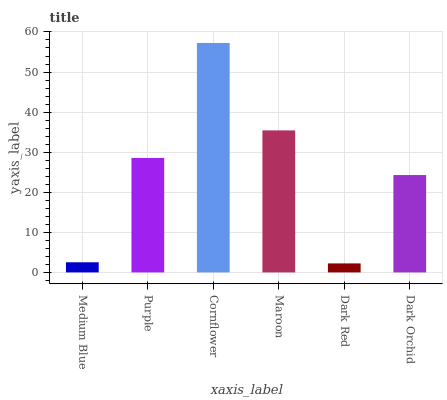Is Dark Red the minimum?
Answer yes or no. Yes. Is Cornflower the maximum?
Answer yes or no. Yes. Is Purple the minimum?
Answer yes or no. No. Is Purple the maximum?
Answer yes or no. No. Is Purple greater than Medium Blue?
Answer yes or no. Yes. Is Medium Blue less than Purple?
Answer yes or no. Yes. Is Medium Blue greater than Purple?
Answer yes or no. No. Is Purple less than Medium Blue?
Answer yes or no. No. Is Purple the high median?
Answer yes or no. Yes. Is Dark Orchid the low median?
Answer yes or no. Yes. Is Maroon the high median?
Answer yes or no. No. Is Dark Red the low median?
Answer yes or no. No. 